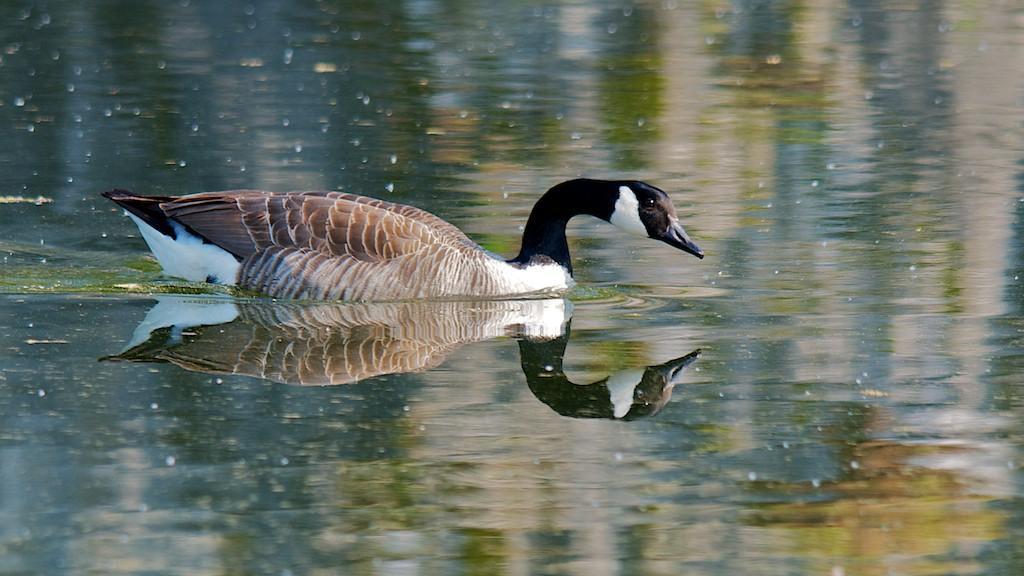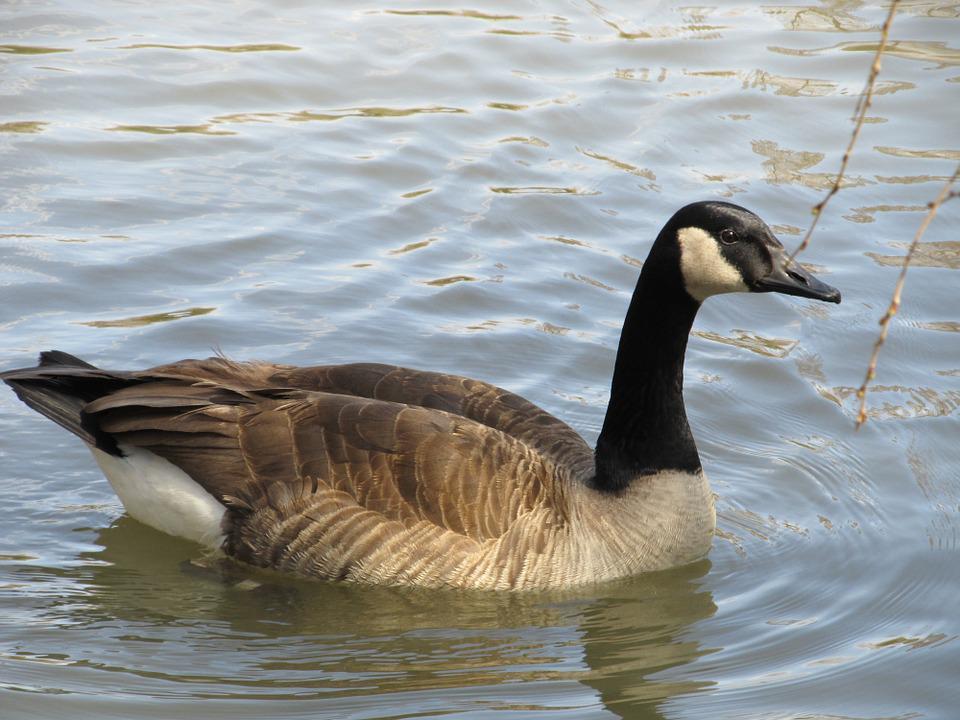The first image is the image on the left, the second image is the image on the right. Evaluate the accuracy of this statement regarding the images: "An image shows exactly two black-necked geese on water, both heading rightward.". Is it true? Answer yes or no. No. The first image is the image on the left, the second image is the image on the right. For the images displayed, is the sentence "The left image contains exactly two ducks both swimming in the same direction." factually correct? Answer yes or no. No. 